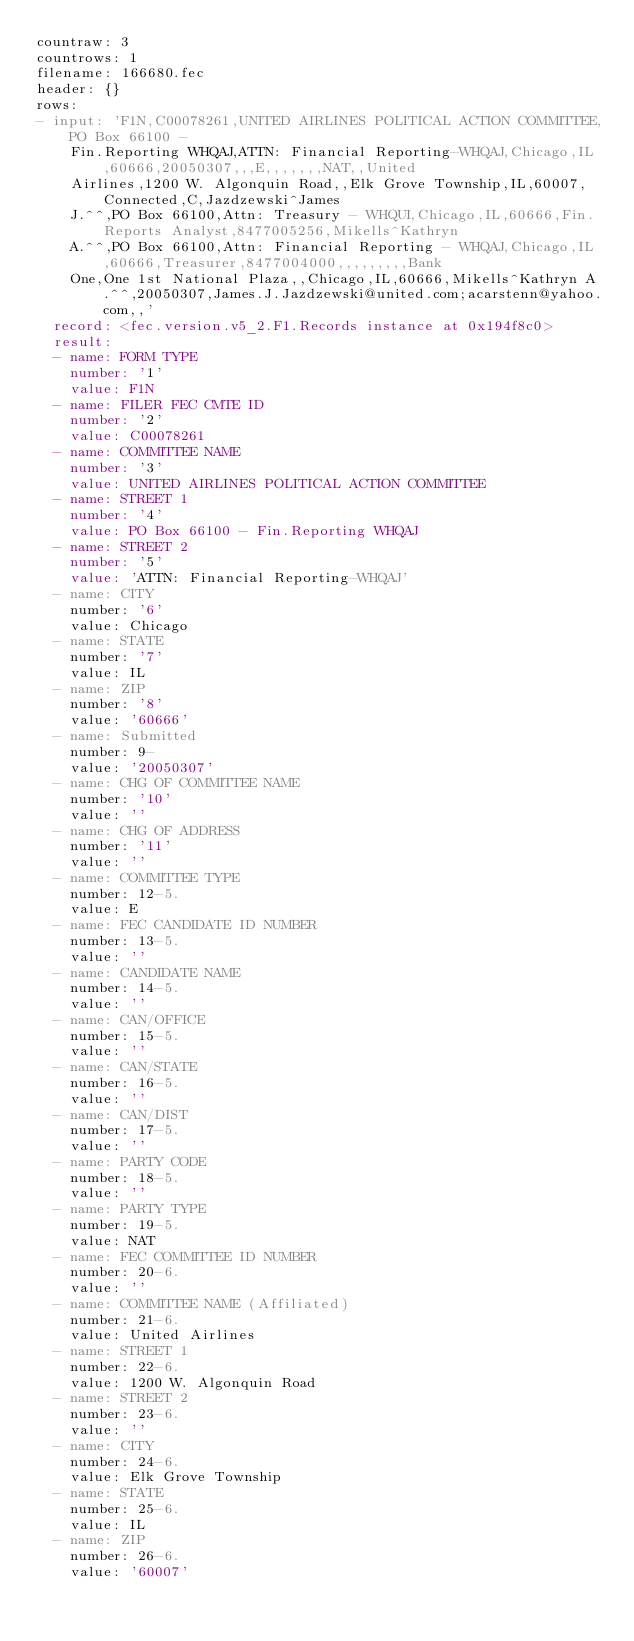<code> <loc_0><loc_0><loc_500><loc_500><_YAML_>countraw: 3
countrows: 1
filename: 166680.fec
header: {}
rows:
- input: 'F1N,C00078261,UNITED AIRLINES POLITICAL ACTION COMMITTEE,PO Box 66100 -
    Fin.Reporting WHQAJ,ATTN: Financial Reporting-WHQAJ,Chicago,IL,60666,20050307,,,E,,,,,,,NAT,,United
    Airlines,1200 W. Algonquin Road,,Elk Grove Township,IL,60007,Connected,C,Jazdzewski^James
    J.^^,PO Box 66100,Attn: Treasury - WHQUI,Chicago,IL,60666,Fin. Reports Analyst,8477005256,Mikells^Kathryn
    A.^^,PO Box 66100,Attn: Financial Reporting - WHQAJ,Chicago,IL,60666,Treasurer,8477004000,,,,,,,,,Bank
    One,One 1st National Plaza,,Chicago,IL,60666,Mikells^Kathryn A.^^,20050307,James.J.Jazdzewski@united.com;acarstenn@yahoo.com,,'
  record: <fec.version.v5_2.F1.Records instance at 0x194f8c0>
  result:
  - name: FORM TYPE
    number: '1'
    value: F1N
  - name: FILER FEC CMTE ID
    number: '2'
    value: C00078261
  - name: COMMITTEE NAME
    number: '3'
    value: UNITED AIRLINES POLITICAL ACTION COMMITTEE
  - name: STREET 1
    number: '4'
    value: PO Box 66100 - Fin.Reporting WHQAJ
  - name: STREET 2
    number: '5'
    value: 'ATTN: Financial Reporting-WHQAJ'
  - name: CITY
    number: '6'
    value: Chicago
  - name: STATE
    number: '7'
    value: IL
  - name: ZIP
    number: '8'
    value: '60666'
  - name: Submitted
    number: 9-
    value: '20050307'
  - name: CHG OF COMMITTEE NAME
    number: '10'
    value: ''
  - name: CHG OF ADDRESS
    number: '11'
    value: ''
  - name: COMMITTEE TYPE
    number: 12-5.
    value: E
  - name: FEC CANDIDATE ID NUMBER
    number: 13-5.
    value: ''
  - name: CANDIDATE NAME
    number: 14-5.
    value: ''
  - name: CAN/OFFICE
    number: 15-5.
    value: ''
  - name: CAN/STATE
    number: 16-5.
    value: ''
  - name: CAN/DIST
    number: 17-5.
    value: ''
  - name: PARTY CODE
    number: 18-5.
    value: ''
  - name: PARTY TYPE
    number: 19-5.
    value: NAT
  - name: FEC COMMITTEE ID NUMBER
    number: 20-6.
    value: ''
  - name: COMMITTEE NAME (Affiliated)
    number: 21-6.
    value: United Airlines
  - name: STREET 1
    number: 22-6.
    value: 1200 W. Algonquin Road
  - name: STREET 2
    number: 23-6.
    value: ''
  - name: CITY
    number: 24-6.
    value: Elk Grove Township
  - name: STATE
    number: 25-6.
    value: IL
  - name: ZIP
    number: 26-6.
    value: '60007'</code> 